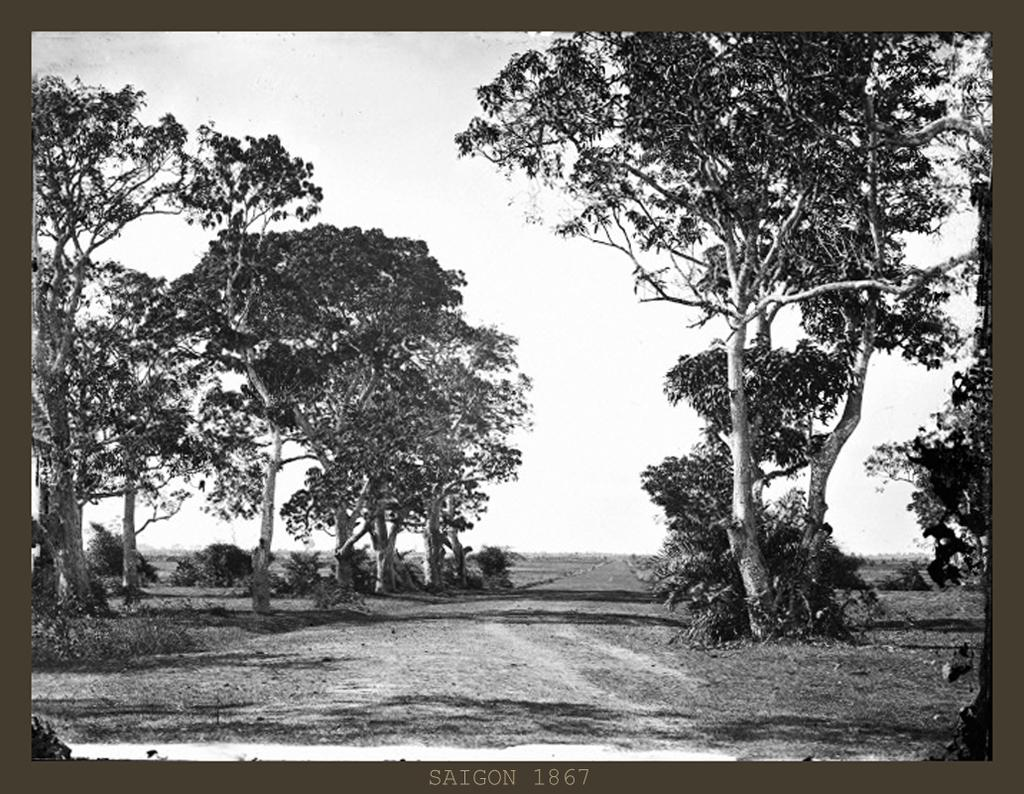What is the color scheme of the image? The image is black and white. What type of terrain can be seen in the image? There is land visible in the image. What type of vegetation is present in the image? There are trees in the image. What is visible at the top of the image? The sky is visible at the top of the image. What type of brass instrument is being played in the image? There is no brass instrument or any musical instruments present in the image. What news headline is visible in the image? There is no text or news headline present in the image; it is a black and white image featuring land, trees, and the sky. 